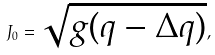<formula> <loc_0><loc_0><loc_500><loc_500>J _ { 0 } = \sqrt { g ( q - \Delta q ) } ,</formula> 